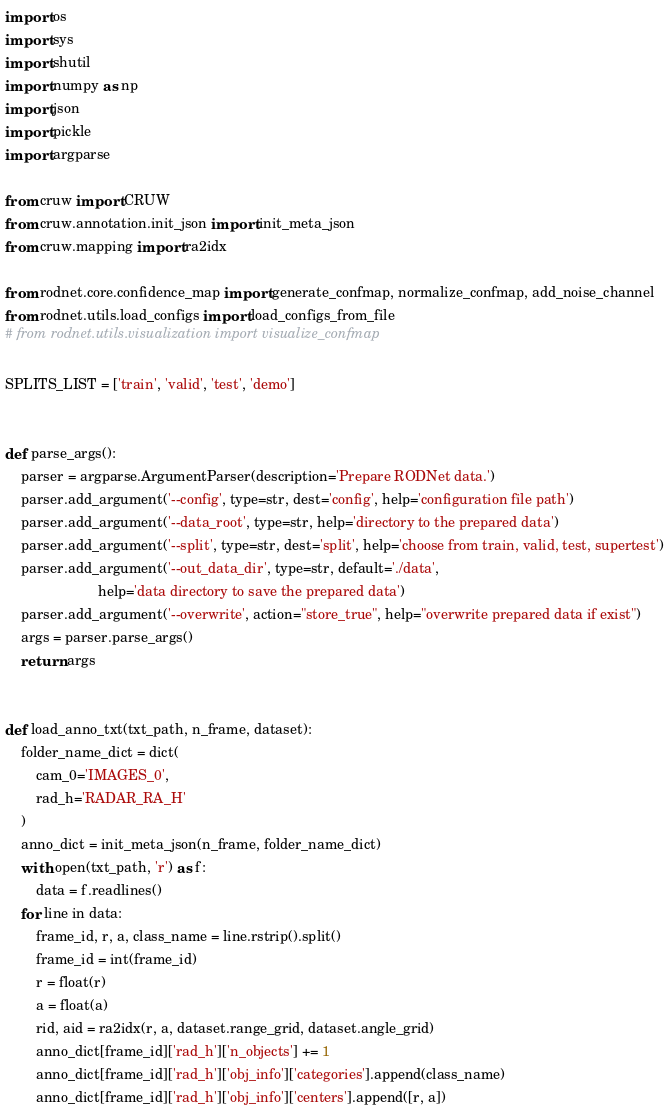Convert code to text. <code><loc_0><loc_0><loc_500><loc_500><_Python_>import os
import sys
import shutil
import numpy as np
import json
import pickle
import argparse

from cruw import CRUW
from cruw.annotation.init_json import init_meta_json
from cruw.mapping import ra2idx

from rodnet.core.confidence_map import generate_confmap, normalize_confmap, add_noise_channel
from rodnet.utils.load_configs import load_configs_from_file
# from rodnet.utils.visualization import visualize_confmap

SPLITS_LIST = ['train', 'valid', 'test', 'demo']


def parse_args():
    parser = argparse.ArgumentParser(description='Prepare RODNet data.')
    parser.add_argument('--config', type=str, dest='config', help='configuration file path')
    parser.add_argument('--data_root', type=str, help='directory to the prepared data')
    parser.add_argument('--split', type=str, dest='split', help='choose from train, valid, test, supertest')
    parser.add_argument('--out_data_dir', type=str, default='./data',
                        help='data directory to save the prepared data')
    parser.add_argument('--overwrite', action="store_true", help="overwrite prepared data if exist")
    args = parser.parse_args()
    return args


def load_anno_txt(txt_path, n_frame, dataset):
    folder_name_dict = dict(
        cam_0='IMAGES_0',
        rad_h='RADAR_RA_H'
    )
    anno_dict = init_meta_json(n_frame, folder_name_dict)
    with open(txt_path, 'r') as f:
        data = f.readlines()
    for line in data:
        frame_id, r, a, class_name = line.rstrip().split()
        frame_id = int(frame_id)
        r = float(r)
        a = float(a)
        rid, aid = ra2idx(r, a, dataset.range_grid, dataset.angle_grid)
        anno_dict[frame_id]['rad_h']['n_objects'] += 1
        anno_dict[frame_id]['rad_h']['obj_info']['categories'].append(class_name)
        anno_dict[frame_id]['rad_h']['obj_info']['centers'].append([r, a])</code> 